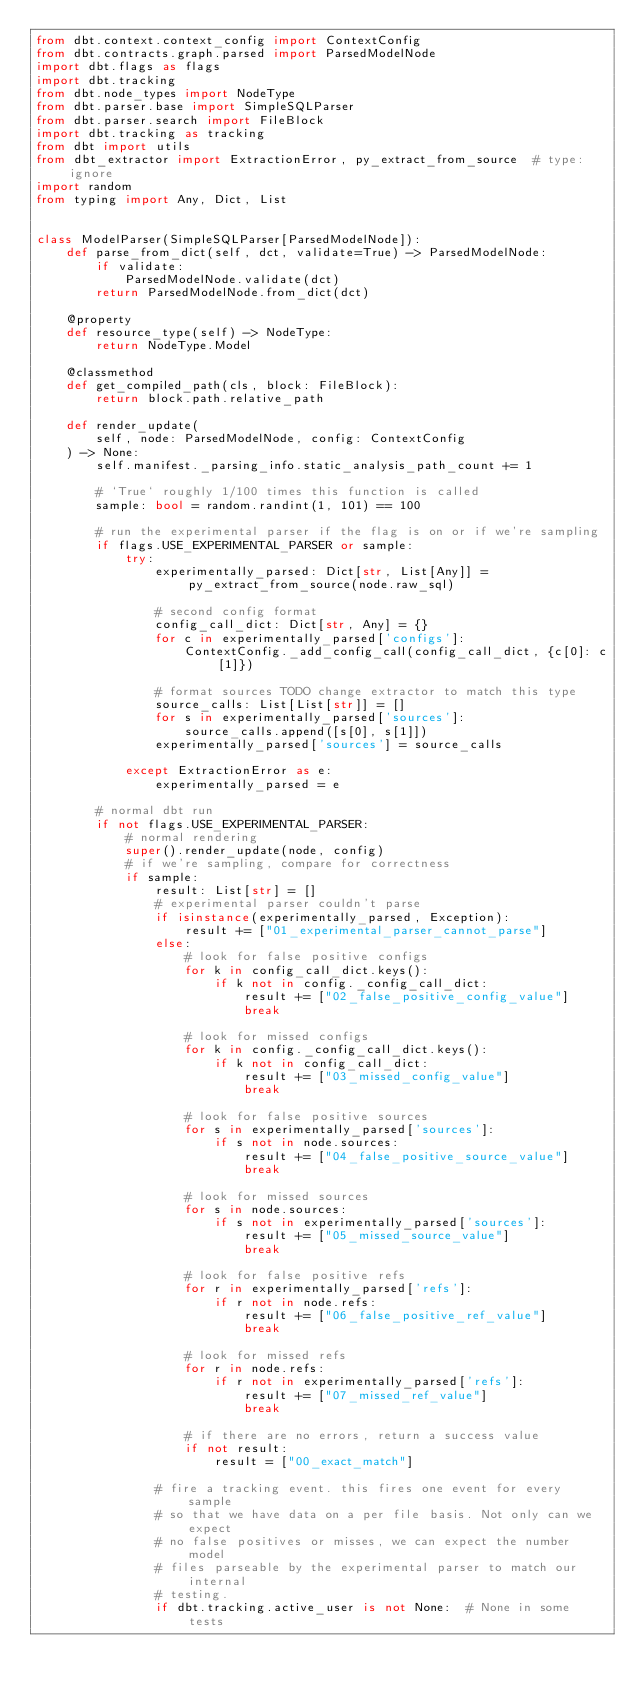Convert code to text. <code><loc_0><loc_0><loc_500><loc_500><_Python_>from dbt.context.context_config import ContextConfig
from dbt.contracts.graph.parsed import ParsedModelNode
import dbt.flags as flags
import dbt.tracking
from dbt.node_types import NodeType
from dbt.parser.base import SimpleSQLParser
from dbt.parser.search import FileBlock
import dbt.tracking as tracking
from dbt import utils
from dbt_extractor import ExtractionError, py_extract_from_source  # type: ignore
import random
from typing import Any, Dict, List


class ModelParser(SimpleSQLParser[ParsedModelNode]):
    def parse_from_dict(self, dct, validate=True) -> ParsedModelNode:
        if validate:
            ParsedModelNode.validate(dct)
        return ParsedModelNode.from_dict(dct)

    @property
    def resource_type(self) -> NodeType:
        return NodeType.Model

    @classmethod
    def get_compiled_path(cls, block: FileBlock):
        return block.path.relative_path

    def render_update(
        self, node: ParsedModelNode, config: ContextConfig
    ) -> None:
        self.manifest._parsing_info.static_analysis_path_count += 1

        # `True` roughly 1/100 times this function is called
        sample: bool = random.randint(1, 101) == 100

        # run the experimental parser if the flag is on or if we're sampling
        if flags.USE_EXPERIMENTAL_PARSER or sample:
            try:
                experimentally_parsed: Dict[str, List[Any]] = py_extract_from_source(node.raw_sql)

                # second config format
                config_call_dict: Dict[str, Any] = {}
                for c in experimentally_parsed['configs']:
                    ContextConfig._add_config_call(config_call_dict, {c[0]: c[1]})

                # format sources TODO change extractor to match this type
                source_calls: List[List[str]] = []
                for s in experimentally_parsed['sources']:
                    source_calls.append([s[0], s[1]])
                experimentally_parsed['sources'] = source_calls

            except ExtractionError as e:
                experimentally_parsed = e

        # normal dbt run
        if not flags.USE_EXPERIMENTAL_PARSER:
            # normal rendering
            super().render_update(node, config)
            # if we're sampling, compare for correctness
            if sample:
                result: List[str] = []
                # experimental parser couldn't parse
                if isinstance(experimentally_parsed, Exception):
                    result += ["01_experimental_parser_cannot_parse"]
                else:
                    # look for false positive configs
                    for k in config_call_dict.keys():
                        if k not in config._config_call_dict:
                            result += ["02_false_positive_config_value"]
                            break

                    # look for missed configs
                    for k in config._config_call_dict.keys():
                        if k not in config_call_dict:
                            result += ["03_missed_config_value"]
                            break

                    # look for false positive sources
                    for s in experimentally_parsed['sources']:
                        if s not in node.sources:
                            result += ["04_false_positive_source_value"]
                            break

                    # look for missed sources
                    for s in node.sources:
                        if s not in experimentally_parsed['sources']:
                            result += ["05_missed_source_value"]
                            break

                    # look for false positive refs
                    for r in experimentally_parsed['refs']:
                        if r not in node.refs:
                            result += ["06_false_positive_ref_value"]
                            break

                    # look for missed refs
                    for r in node.refs:
                        if r not in experimentally_parsed['refs']:
                            result += ["07_missed_ref_value"]
                            break

                    # if there are no errors, return a success value
                    if not result:
                        result = ["00_exact_match"]

                # fire a tracking event. this fires one event for every sample
                # so that we have data on a per file basis. Not only can we expect
                # no false positives or misses, we can expect the number model
                # files parseable by the experimental parser to match our internal
                # testing.
                if dbt.tracking.active_user is not None:  # None in some tests</code> 